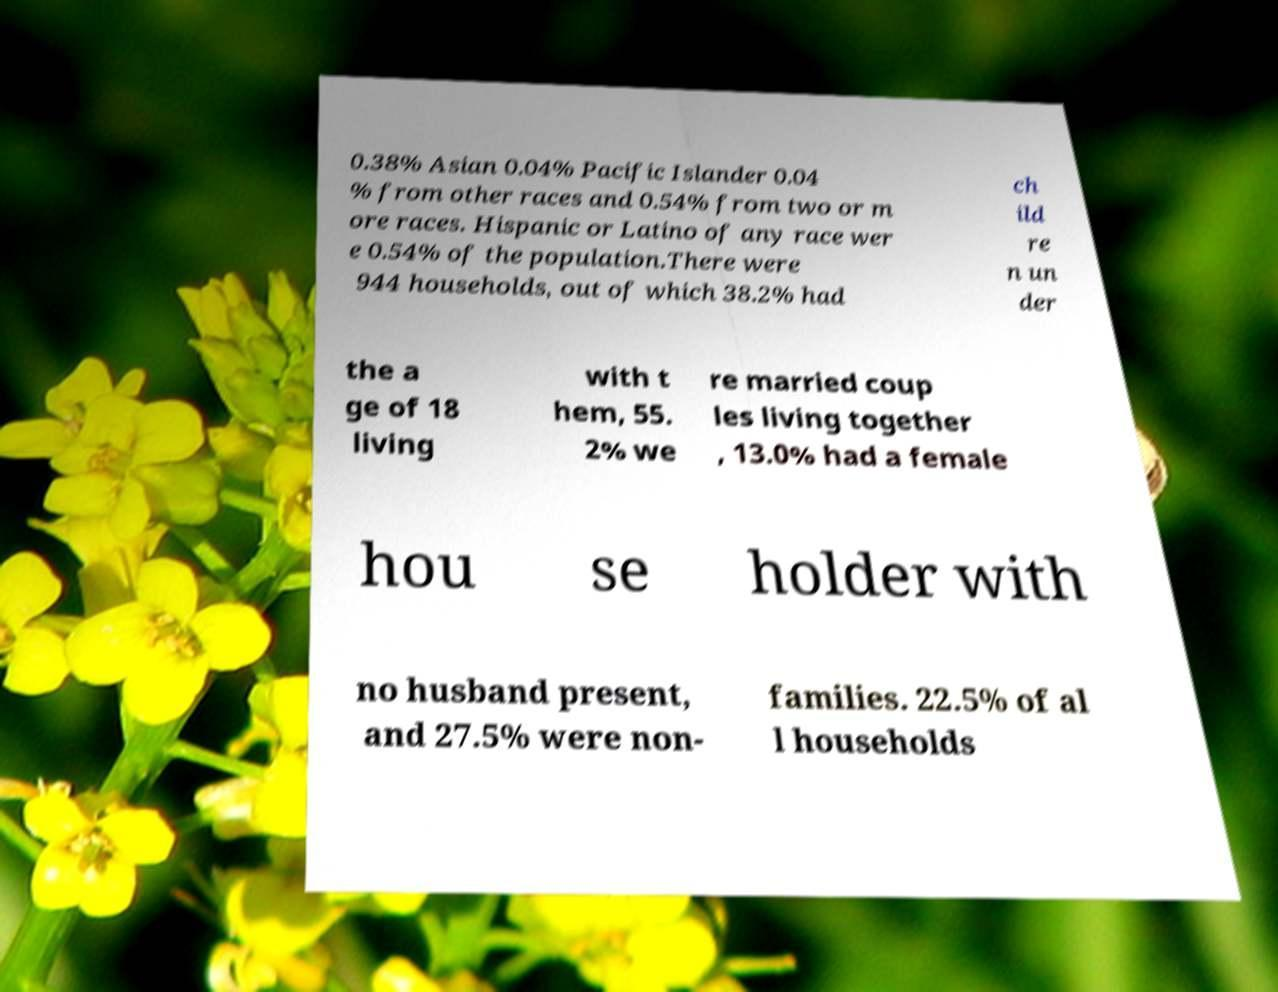For documentation purposes, I need the text within this image transcribed. Could you provide that? 0.38% Asian 0.04% Pacific Islander 0.04 % from other races and 0.54% from two or m ore races. Hispanic or Latino of any race wer e 0.54% of the population.There were 944 households, out of which 38.2% had ch ild re n un der the a ge of 18 living with t hem, 55. 2% we re married coup les living together , 13.0% had a female hou se holder with no husband present, and 27.5% were non- families. 22.5% of al l households 